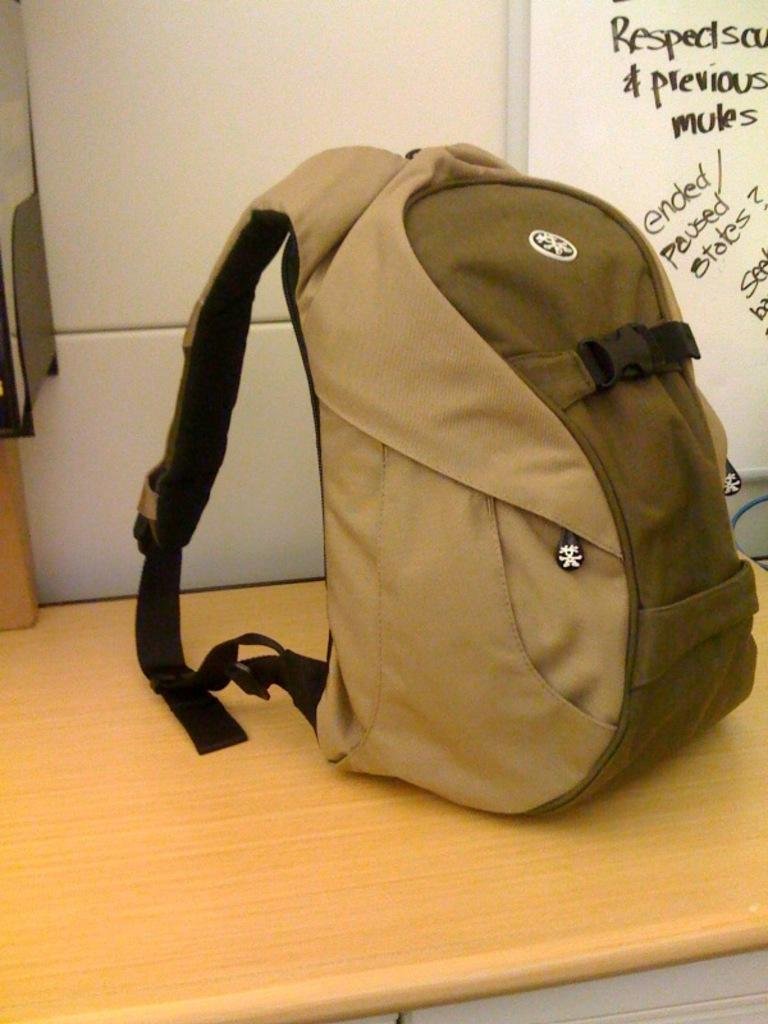<image>
Offer a succinct explanation of the picture presented. A backpack sits in front of a whiteboard that has information about mules on it. 